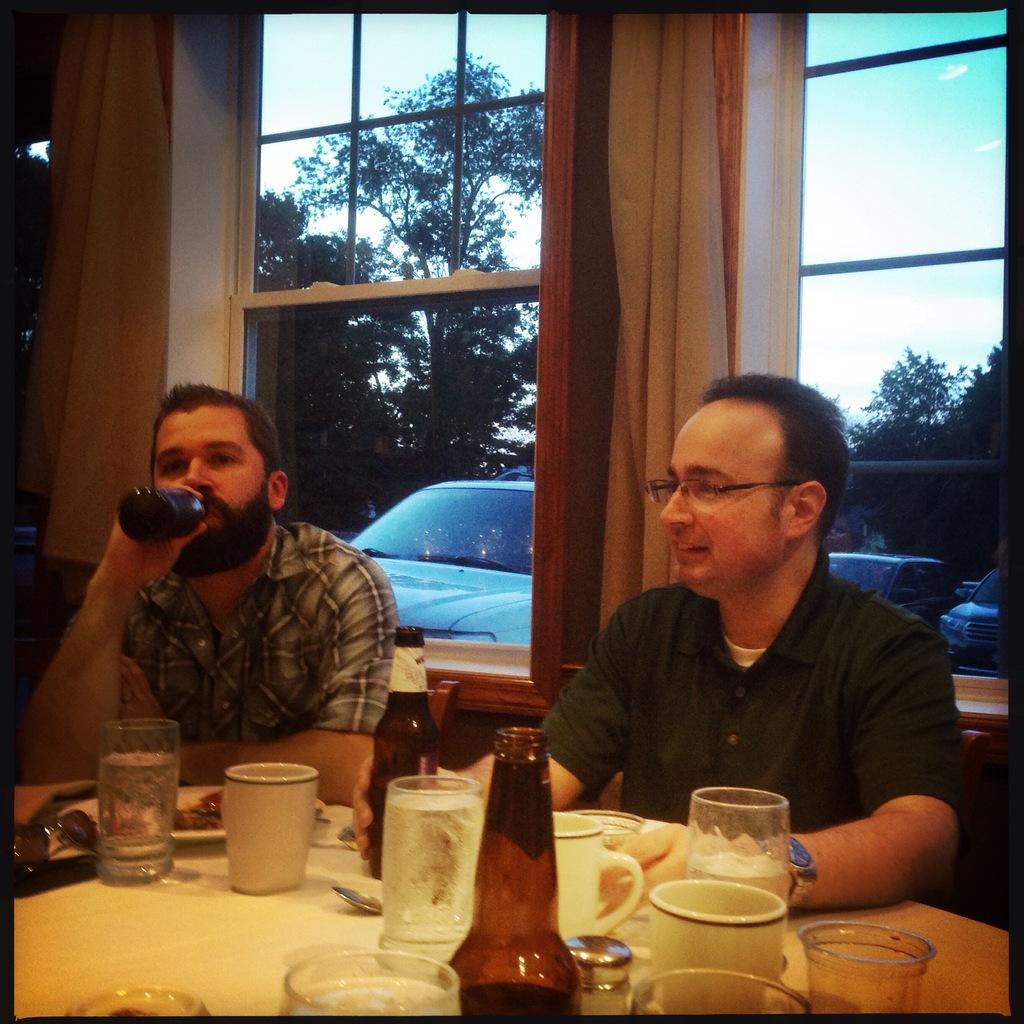Please provide a concise description of this image. In this picture we can see two people sitting on the chair in front of a table and on table we have some glasses, bottles and some food. Behind them there is a window which has a curtain and we can see cars and some trees. 